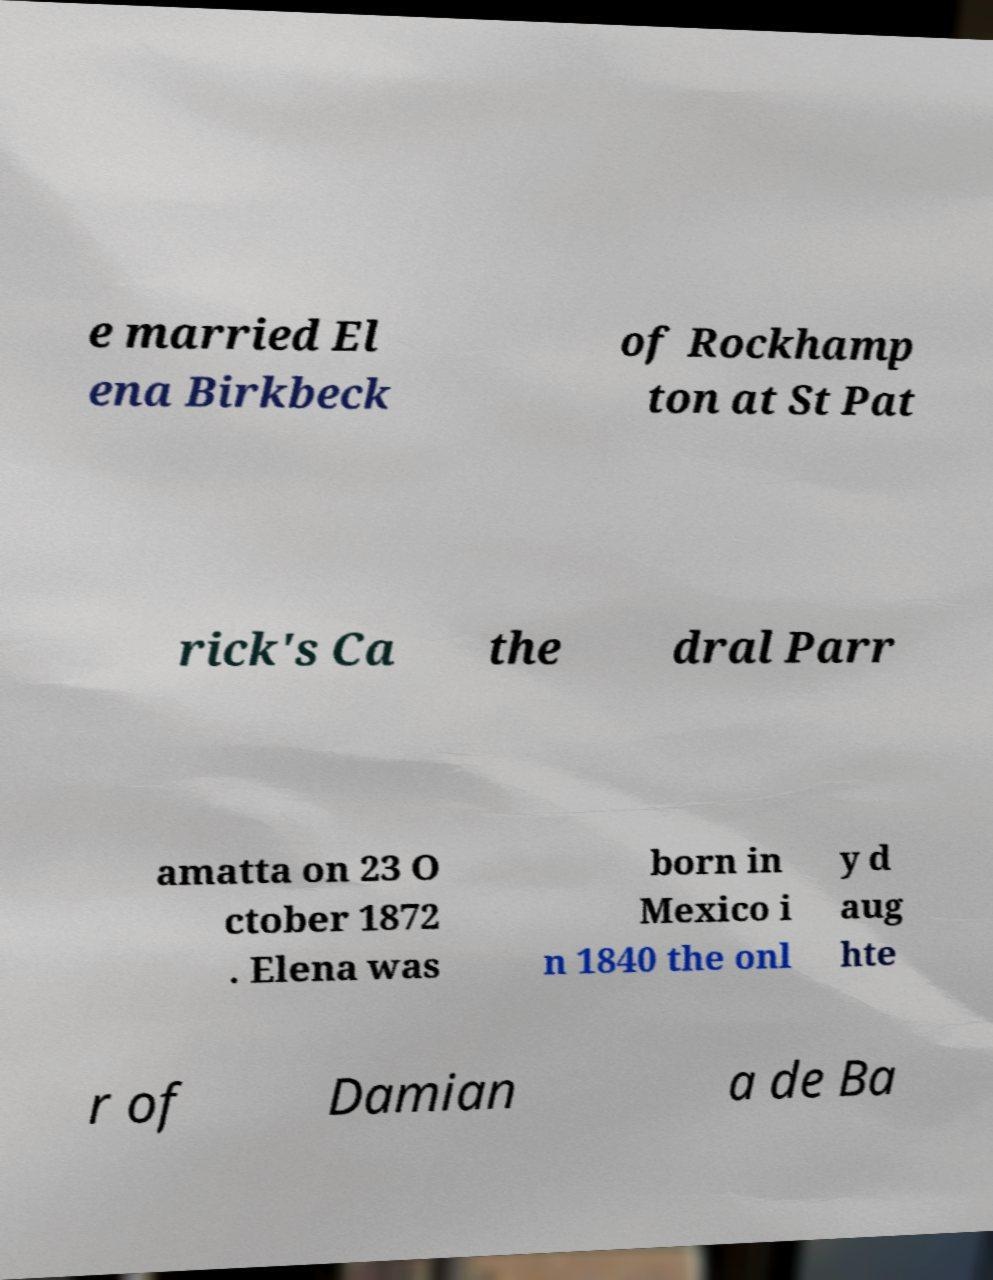I need the written content from this picture converted into text. Can you do that? e married El ena Birkbeck of Rockhamp ton at St Pat rick's Ca the dral Parr amatta on 23 O ctober 1872 . Elena was born in Mexico i n 1840 the onl y d aug hte r of Damian a de Ba 